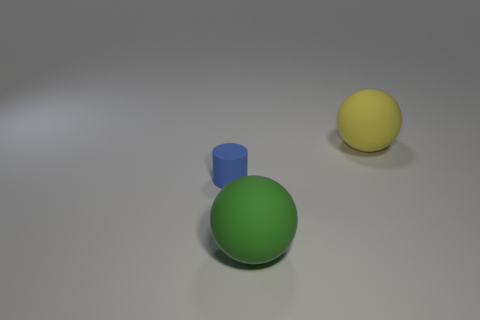Add 1 red metal cubes. How many objects exist? 4 Subtract all yellow spheres. How many spheres are left? 1 Subtract all balls. How many objects are left? 1 Subtract 1 cylinders. How many cylinders are left? 0 Subtract 0 purple cylinders. How many objects are left? 3 Subtract all purple balls. Subtract all blue blocks. How many balls are left? 2 Subtract all big green matte spheres. Subtract all large matte spheres. How many objects are left? 0 Add 1 tiny blue matte cylinders. How many tiny blue matte cylinders are left? 2 Add 3 small blue cylinders. How many small blue cylinders exist? 4 